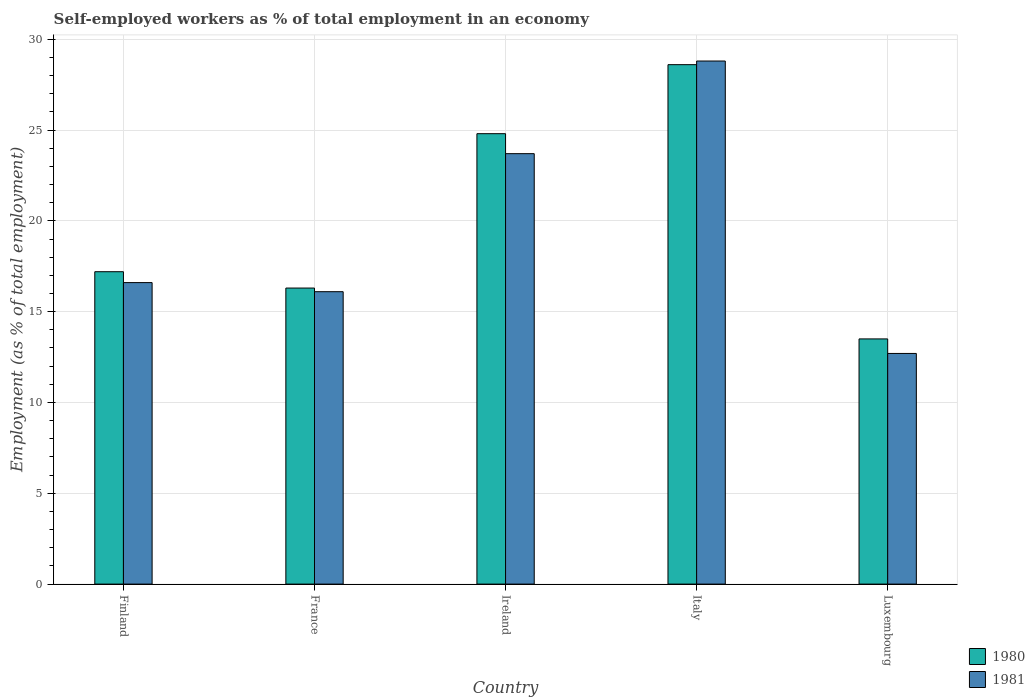How many different coloured bars are there?
Your answer should be compact. 2. Are the number of bars per tick equal to the number of legend labels?
Offer a terse response. Yes. How many bars are there on the 3rd tick from the left?
Give a very brief answer. 2. How many bars are there on the 5th tick from the right?
Ensure brevity in your answer.  2. In how many cases, is the number of bars for a given country not equal to the number of legend labels?
Provide a succinct answer. 0. What is the percentage of self-employed workers in 1980 in Ireland?
Your response must be concise. 24.8. Across all countries, what is the maximum percentage of self-employed workers in 1980?
Offer a terse response. 28.6. In which country was the percentage of self-employed workers in 1980 minimum?
Make the answer very short. Luxembourg. What is the total percentage of self-employed workers in 1981 in the graph?
Your answer should be compact. 97.9. What is the difference between the percentage of self-employed workers in 1981 in Finland and that in Italy?
Your response must be concise. -12.2. What is the difference between the percentage of self-employed workers in 1981 in France and the percentage of self-employed workers in 1980 in Finland?
Your response must be concise. -1.1. What is the average percentage of self-employed workers in 1980 per country?
Keep it short and to the point. 20.08. What is the difference between the percentage of self-employed workers of/in 1981 and percentage of self-employed workers of/in 1980 in Italy?
Ensure brevity in your answer.  0.2. What is the ratio of the percentage of self-employed workers in 1980 in Finland to that in Ireland?
Your answer should be very brief. 0.69. What is the difference between the highest and the second highest percentage of self-employed workers in 1981?
Offer a terse response. -12.2. What is the difference between the highest and the lowest percentage of self-employed workers in 1980?
Your answer should be very brief. 15.1. In how many countries, is the percentage of self-employed workers in 1981 greater than the average percentage of self-employed workers in 1981 taken over all countries?
Your response must be concise. 2. Is the sum of the percentage of self-employed workers in 1981 in Finland and France greater than the maximum percentage of self-employed workers in 1980 across all countries?
Give a very brief answer. Yes. What does the 1st bar from the left in Luxembourg represents?
Ensure brevity in your answer.  1980. What does the 1st bar from the right in Ireland represents?
Ensure brevity in your answer.  1981. How many bars are there?
Give a very brief answer. 10. How many countries are there in the graph?
Offer a terse response. 5. Does the graph contain any zero values?
Provide a short and direct response. No. How are the legend labels stacked?
Provide a succinct answer. Vertical. What is the title of the graph?
Offer a very short reply. Self-employed workers as % of total employment in an economy. Does "1973" appear as one of the legend labels in the graph?
Your answer should be compact. No. What is the label or title of the Y-axis?
Offer a terse response. Employment (as % of total employment). What is the Employment (as % of total employment) of 1980 in Finland?
Your response must be concise. 17.2. What is the Employment (as % of total employment) in 1981 in Finland?
Offer a terse response. 16.6. What is the Employment (as % of total employment) of 1980 in France?
Your answer should be very brief. 16.3. What is the Employment (as % of total employment) in 1981 in France?
Ensure brevity in your answer.  16.1. What is the Employment (as % of total employment) in 1980 in Ireland?
Keep it short and to the point. 24.8. What is the Employment (as % of total employment) in 1981 in Ireland?
Give a very brief answer. 23.7. What is the Employment (as % of total employment) of 1980 in Italy?
Your answer should be compact. 28.6. What is the Employment (as % of total employment) of 1981 in Italy?
Give a very brief answer. 28.8. What is the Employment (as % of total employment) of 1980 in Luxembourg?
Offer a terse response. 13.5. What is the Employment (as % of total employment) in 1981 in Luxembourg?
Provide a short and direct response. 12.7. Across all countries, what is the maximum Employment (as % of total employment) in 1980?
Your response must be concise. 28.6. Across all countries, what is the maximum Employment (as % of total employment) in 1981?
Offer a terse response. 28.8. Across all countries, what is the minimum Employment (as % of total employment) of 1980?
Provide a short and direct response. 13.5. Across all countries, what is the minimum Employment (as % of total employment) in 1981?
Give a very brief answer. 12.7. What is the total Employment (as % of total employment) of 1980 in the graph?
Keep it short and to the point. 100.4. What is the total Employment (as % of total employment) of 1981 in the graph?
Ensure brevity in your answer.  97.9. What is the difference between the Employment (as % of total employment) of 1980 in Finland and that in Ireland?
Your answer should be compact. -7.6. What is the difference between the Employment (as % of total employment) in 1981 in Finland and that in Ireland?
Your response must be concise. -7.1. What is the difference between the Employment (as % of total employment) in 1981 in Finland and that in Italy?
Give a very brief answer. -12.2. What is the difference between the Employment (as % of total employment) in 1980 in Finland and that in Luxembourg?
Make the answer very short. 3.7. What is the difference between the Employment (as % of total employment) of 1980 in France and that in Ireland?
Ensure brevity in your answer.  -8.5. What is the difference between the Employment (as % of total employment) in 1981 in France and that in Ireland?
Offer a terse response. -7.6. What is the difference between the Employment (as % of total employment) of 1980 in France and that in Italy?
Offer a very short reply. -12.3. What is the difference between the Employment (as % of total employment) in 1980 in France and that in Luxembourg?
Provide a succinct answer. 2.8. What is the difference between the Employment (as % of total employment) in 1980 in Ireland and that in Italy?
Your response must be concise. -3.8. What is the difference between the Employment (as % of total employment) of 1980 in Ireland and that in Luxembourg?
Offer a very short reply. 11.3. What is the difference between the Employment (as % of total employment) of 1980 in Italy and that in Luxembourg?
Your response must be concise. 15.1. What is the difference between the Employment (as % of total employment) of 1981 in Italy and that in Luxembourg?
Offer a terse response. 16.1. What is the difference between the Employment (as % of total employment) of 1980 in Finland and the Employment (as % of total employment) of 1981 in France?
Offer a terse response. 1.1. What is the difference between the Employment (as % of total employment) in 1980 in Finland and the Employment (as % of total employment) in 1981 in Ireland?
Give a very brief answer. -6.5. What is the difference between the Employment (as % of total employment) of 1980 in Finland and the Employment (as % of total employment) of 1981 in Italy?
Offer a terse response. -11.6. What is the difference between the Employment (as % of total employment) of 1980 in France and the Employment (as % of total employment) of 1981 in Ireland?
Your answer should be very brief. -7.4. What is the difference between the Employment (as % of total employment) of 1980 in France and the Employment (as % of total employment) of 1981 in Italy?
Ensure brevity in your answer.  -12.5. What is the difference between the Employment (as % of total employment) of 1980 in Ireland and the Employment (as % of total employment) of 1981 in Luxembourg?
Give a very brief answer. 12.1. What is the average Employment (as % of total employment) of 1980 per country?
Your answer should be very brief. 20.08. What is the average Employment (as % of total employment) in 1981 per country?
Provide a short and direct response. 19.58. What is the difference between the Employment (as % of total employment) of 1980 and Employment (as % of total employment) of 1981 in Finland?
Your response must be concise. 0.6. What is the difference between the Employment (as % of total employment) in 1980 and Employment (as % of total employment) in 1981 in France?
Keep it short and to the point. 0.2. What is the difference between the Employment (as % of total employment) in 1980 and Employment (as % of total employment) in 1981 in Luxembourg?
Provide a short and direct response. 0.8. What is the ratio of the Employment (as % of total employment) of 1980 in Finland to that in France?
Your answer should be very brief. 1.06. What is the ratio of the Employment (as % of total employment) in 1981 in Finland to that in France?
Make the answer very short. 1.03. What is the ratio of the Employment (as % of total employment) in 1980 in Finland to that in Ireland?
Give a very brief answer. 0.69. What is the ratio of the Employment (as % of total employment) in 1981 in Finland to that in Ireland?
Your response must be concise. 0.7. What is the ratio of the Employment (as % of total employment) of 1980 in Finland to that in Italy?
Give a very brief answer. 0.6. What is the ratio of the Employment (as % of total employment) of 1981 in Finland to that in Italy?
Offer a terse response. 0.58. What is the ratio of the Employment (as % of total employment) of 1980 in Finland to that in Luxembourg?
Offer a terse response. 1.27. What is the ratio of the Employment (as % of total employment) in 1981 in Finland to that in Luxembourg?
Provide a short and direct response. 1.31. What is the ratio of the Employment (as % of total employment) of 1980 in France to that in Ireland?
Give a very brief answer. 0.66. What is the ratio of the Employment (as % of total employment) in 1981 in France to that in Ireland?
Provide a short and direct response. 0.68. What is the ratio of the Employment (as % of total employment) of 1980 in France to that in Italy?
Make the answer very short. 0.57. What is the ratio of the Employment (as % of total employment) of 1981 in France to that in Italy?
Provide a short and direct response. 0.56. What is the ratio of the Employment (as % of total employment) in 1980 in France to that in Luxembourg?
Provide a succinct answer. 1.21. What is the ratio of the Employment (as % of total employment) of 1981 in France to that in Luxembourg?
Provide a short and direct response. 1.27. What is the ratio of the Employment (as % of total employment) in 1980 in Ireland to that in Italy?
Your response must be concise. 0.87. What is the ratio of the Employment (as % of total employment) in 1981 in Ireland to that in Italy?
Your answer should be compact. 0.82. What is the ratio of the Employment (as % of total employment) of 1980 in Ireland to that in Luxembourg?
Provide a succinct answer. 1.84. What is the ratio of the Employment (as % of total employment) in 1981 in Ireland to that in Luxembourg?
Your answer should be very brief. 1.87. What is the ratio of the Employment (as % of total employment) in 1980 in Italy to that in Luxembourg?
Your response must be concise. 2.12. What is the ratio of the Employment (as % of total employment) in 1981 in Italy to that in Luxembourg?
Ensure brevity in your answer.  2.27. What is the difference between the highest and the lowest Employment (as % of total employment) of 1981?
Provide a short and direct response. 16.1. 